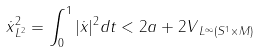<formula> <loc_0><loc_0><loc_500><loc_500>\| \dot { x } \| _ { L ^ { 2 } } ^ { 2 } = \int _ { 0 } ^ { 1 } | \dot { x } | ^ { 2 } d t < 2 a + 2 \| V \| _ { L ^ { \infty } ( S ^ { 1 } \times M ) }</formula> 